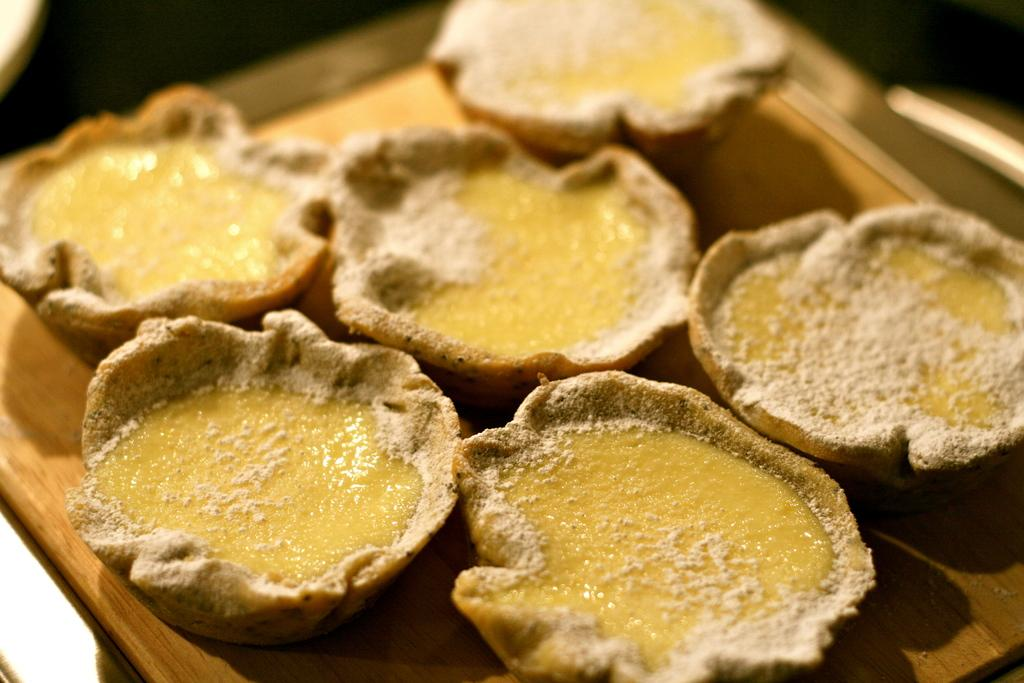What is present on the tray in the image? There are food items on a tray in the image. What type of building can be seen in the background of the image? There is no background or building present in the image; it only shows food items on a tray. 